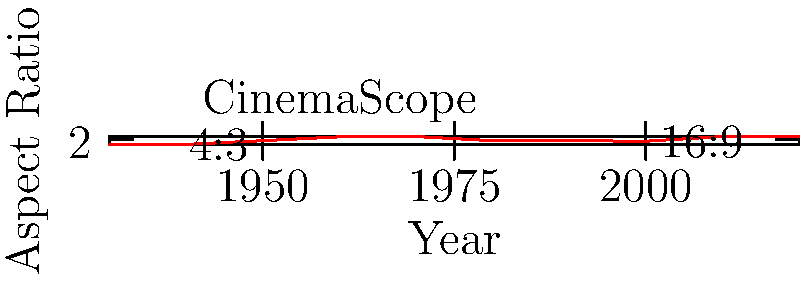Analyze the graph showing the evolution of film aspect ratios from 1930 to 2020. How does the trend in aspect ratios correlate with societal changes and the portrayal of constraints in cinema? Specifically, what might the shift from the 4:3 ratio to wider formats suggest about changing societal perspectives? To answer this question, we need to analyze the graph and consider the societal context of each era:

1. 1930s-1940s: The graph shows a consistent use of the 4:3 (1.33:1) aspect ratio. This was the standard for early cinema and television, reflecting a more constrained view of society.

2. 1950s-1960s: There's a dramatic increase in aspect ratios, with the introduction of widescreen formats like CinemaScope (2.35:1). This coincides with the post-war boom and expanding societal horizons.

3. 1970s-1980s: The aspect ratio remains wide but varies, suggesting experimentation and diversity in filmmaking approaches, mirroring societal changes of the era.

4. 1990s-2000s: There's a slight decrease in aspect ratios, with 16:9 (1.78:1) becoming prominent, likely due to the rise of home entertainment and digital formats.

5. 2010s-2020: The ratio increases again to 2.39:1, possibly reflecting a return to cinematic spectacle in response to streaming services.

The shift from 4:3 to wider formats suggests:

1. Expanded worldviews: Wider screens can represent broader perspectives and a less constrained society.
2. Technological progress: The ability to create wider images reflects advancements in film technology and society.
3. Changing narrative focus: Wider ratios allow for more expansive storytelling, possibly indicating a shift from individual-focused narratives to broader societal themes.
4. Visual freedom: The wider frame provides more space for visual composition, potentially symbolizing increased personal and creative freedom in society.

This analysis shows how aspect ratios can be seen as a visual metaphor for societal constraints and freedoms over time.
Answer: Wider aspect ratios correlate with expanding societal perspectives, technological progress, and increased focus on broader narratives, reflecting a shift from constrained to more open societal views. 